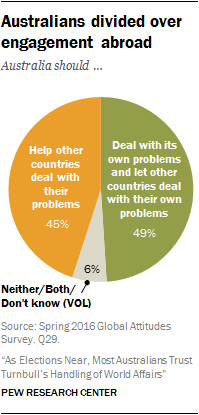List a handful of essential elements in this visual. Sixty-five percent of respondents chose the option 'Don't know' in the survey. 94% of people are choosing an option other than "don't know. 